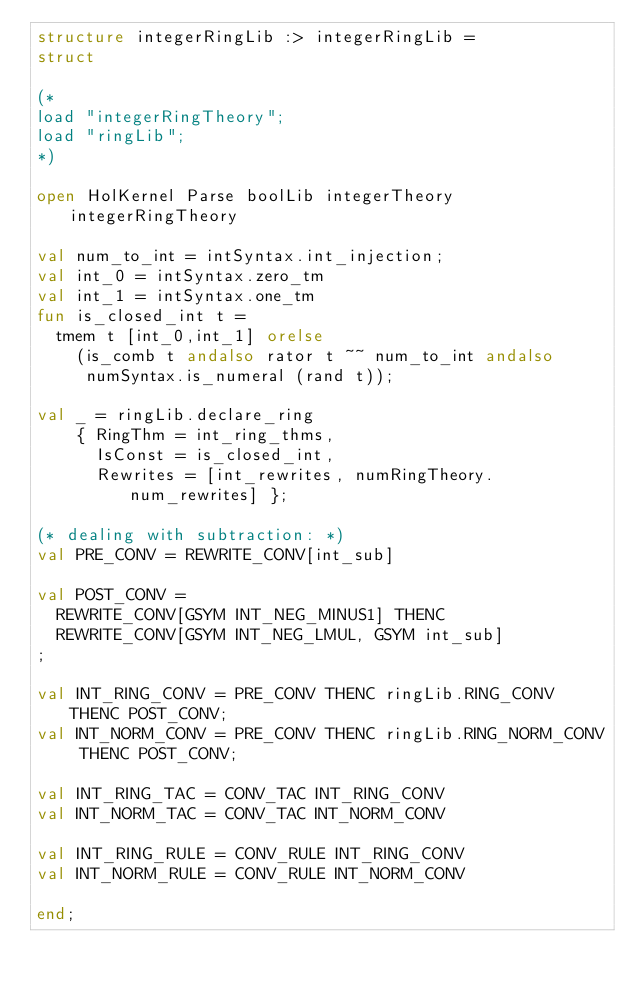Convert code to text. <code><loc_0><loc_0><loc_500><loc_500><_SML_>structure integerRingLib :> integerRingLib =
struct

(*
load "integerRingTheory";
load "ringLib";
*)

open HolKernel Parse boolLib integerTheory integerRingTheory

val num_to_int = intSyntax.int_injection;
val int_0 = intSyntax.zero_tm
val int_1 = intSyntax.one_tm
fun is_closed_int t =
  tmem t [int_0,int_1] orelse
    (is_comb t andalso rator t ~~ num_to_int andalso
     numSyntax.is_numeral (rand t));

val _ = ringLib.declare_ring
    { RingThm = int_ring_thms,
      IsConst = is_closed_int,
      Rewrites = [int_rewrites, numRingTheory.num_rewrites] };

(* dealing with subtraction: *)
val PRE_CONV = REWRITE_CONV[int_sub]

val POST_CONV =
  REWRITE_CONV[GSYM INT_NEG_MINUS1] THENC
  REWRITE_CONV[GSYM INT_NEG_LMUL, GSYM int_sub]
;

val INT_RING_CONV = PRE_CONV THENC ringLib.RING_CONV THENC POST_CONV;
val INT_NORM_CONV = PRE_CONV THENC ringLib.RING_NORM_CONV THENC POST_CONV;

val INT_RING_TAC = CONV_TAC INT_RING_CONV
val INT_NORM_TAC = CONV_TAC INT_NORM_CONV

val INT_RING_RULE = CONV_RULE INT_RING_CONV
val INT_NORM_RULE = CONV_RULE INT_NORM_CONV

end;
</code> 